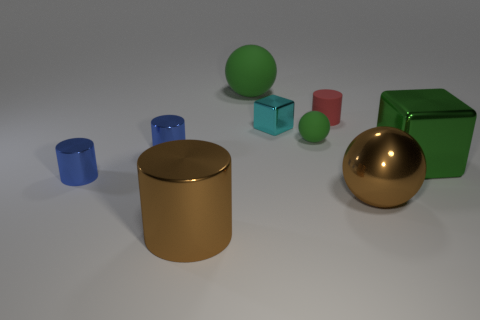What number of large green objects are there?
Your answer should be very brief. 2. Is the shape of the cyan metal thing the same as the matte thing that is in front of the small red cylinder?
Your response must be concise. No. There is a brown metallic thing that is to the right of the big shiny cylinder; how big is it?
Offer a very short reply. Large. What is the green cube made of?
Your answer should be compact. Metal. There is a tiny thing in front of the green metal object; does it have the same shape as the tiny cyan metal thing?
Provide a succinct answer. No. There is a matte thing that is the same color as the big matte ball; what size is it?
Your answer should be very brief. Small. Is there a brown thing of the same size as the cyan cube?
Provide a short and direct response. No. There is a tiny blue metal thing behind the big green thing in front of the big rubber object; are there any tiny blue metal cylinders that are behind it?
Ensure brevity in your answer.  No. Does the big matte object have the same color as the small cylinder on the right side of the big rubber sphere?
Your response must be concise. No. What material is the brown object that is to the right of the thing in front of the big brown metal object right of the brown cylinder?
Your answer should be very brief. Metal. 